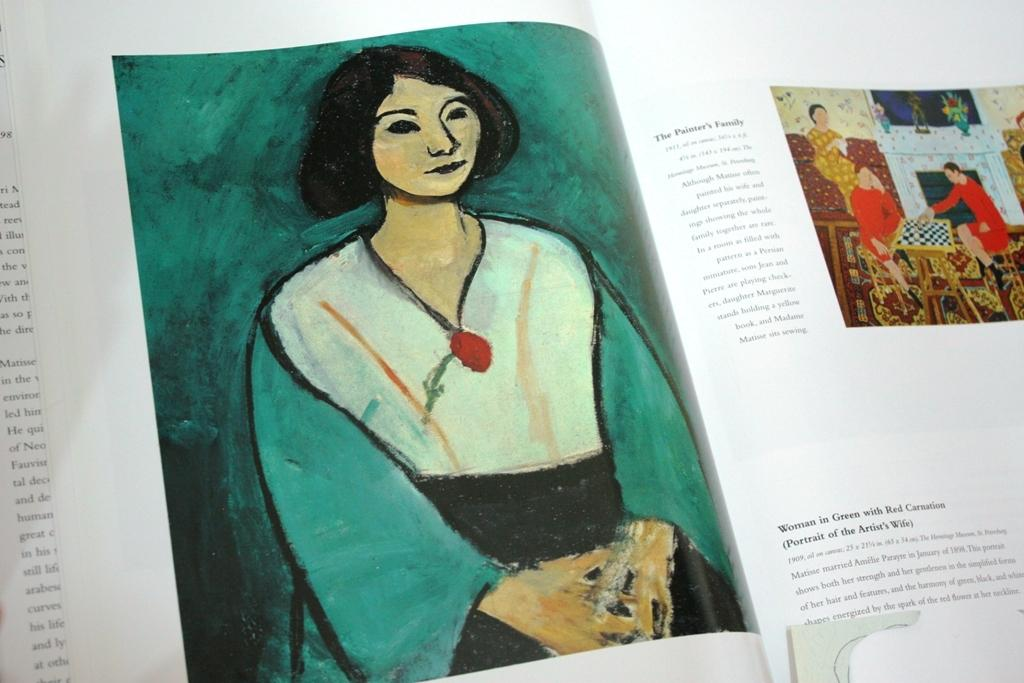What is the main object in the center of the image? There is a book in the center of the image. What is happening with the book in the image? A person is standing on the book, and there are people sitting on the book. Is there any text or writing visible in the image? Yes, there is something written on a paper. How many chickens are present in the image? There are no chickens present in the image. What color is the spot on the book in the image? The image does not mention a spot on the book, so we cannot determine the color of a spot that is not present in the image. 